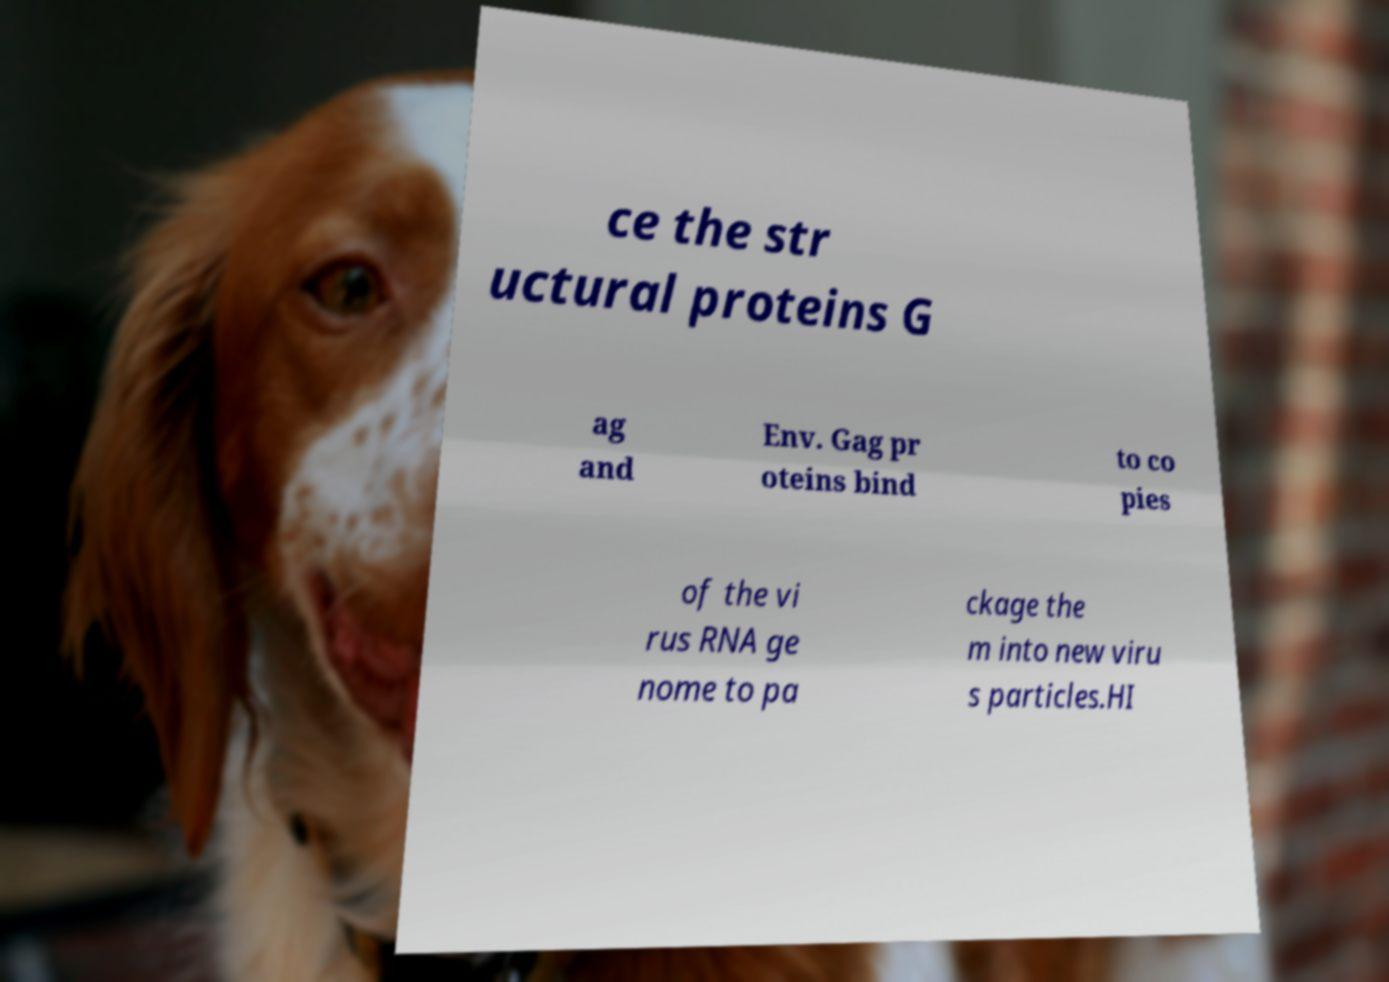I need the written content from this picture converted into text. Can you do that? ce the str uctural proteins G ag and Env. Gag pr oteins bind to co pies of the vi rus RNA ge nome to pa ckage the m into new viru s particles.HI 